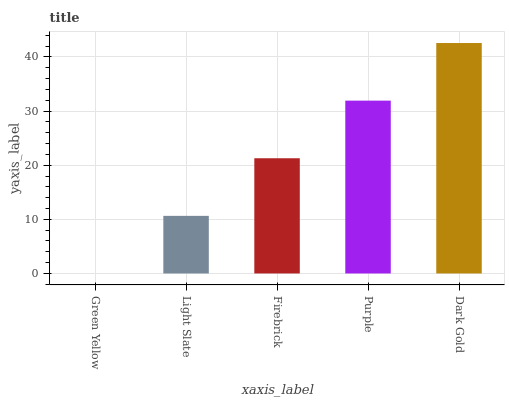Is Green Yellow the minimum?
Answer yes or no. Yes. Is Dark Gold the maximum?
Answer yes or no. Yes. Is Light Slate the minimum?
Answer yes or no. No. Is Light Slate the maximum?
Answer yes or no. No. Is Light Slate greater than Green Yellow?
Answer yes or no. Yes. Is Green Yellow less than Light Slate?
Answer yes or no. Yes. Is Green Yellow greater than Light Slate?
Answer yes or no. No. Is Light Slate less than Green Yellow?
Answer yes or no. No. Is Firebrick the high median?
Answer yes or no. Yes. Is Firebrick the low median?
Answer yes or no. Yes. Is Green Yellow the high median?
Answer yes or no. No. Is Light Slate the low median?
Answer yes or no. No. 